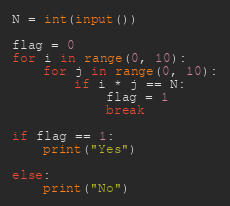<code> <loc_0><loc_0><loc_500><loc_500><_Python_>N = int(input())

flag = 0
for i in range(0, 10):
    for j in range(0, 10):
        if i * j == N:
            flag = 1
            break

if flag == 1:
    print("Yes")

else:
    print("No")</code> 